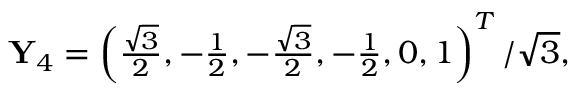Convert formula to latex. <formula><loc_0><loc_0><loc_500><loc_500>\begin{array} { r } { Y _ { 4 } = \left ( \frac { \sqrt { 3 } } { 2 } , - \frac { 1 } { 2 } , - \frac { \sqrt { 3 } } { 2 } , - \frac { 1 } { 2 } , 0 , 1 \right ) ^ { T } / \sqrt { 3 } , } \end{array}</formula> 